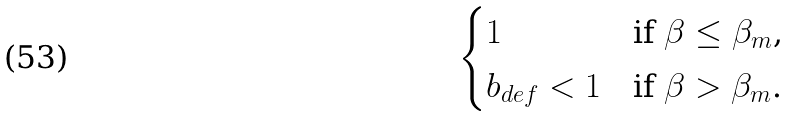Convert formula to latex. <formula><loc_0><loc_0><loc_500><loc_500>\begin{cases} 1 & \text {if $\beta \leq \beta_{m}$, } \\ b _ { d e f } < 1 & \text {if $\beta > \beta_{m}$.} \end{cases}</formula> 